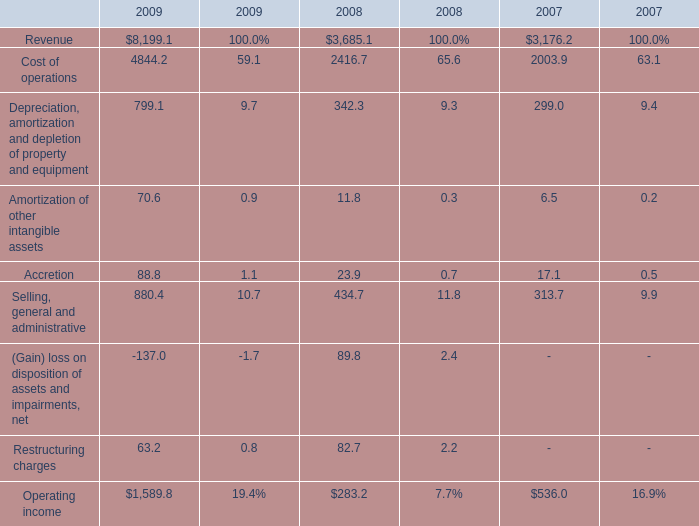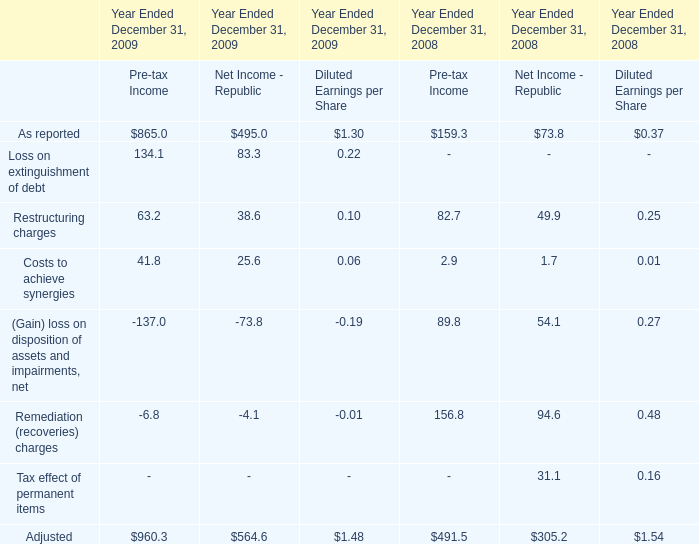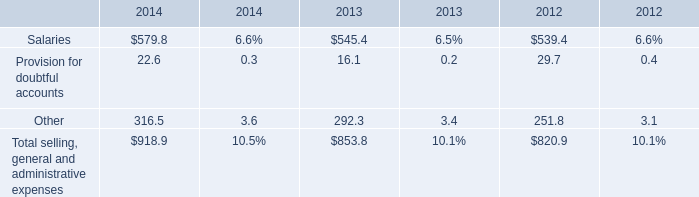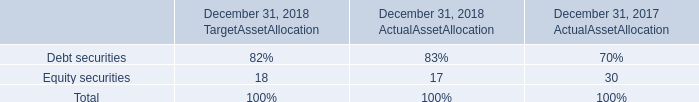If Cost of operations develops with the same growth rate in 2009, what will it reach in 2010? 
Computations: (4844.2 * (1 + ((4844.2 - 2416.7) / 2416.7)))
Answer: 9710.04826. 